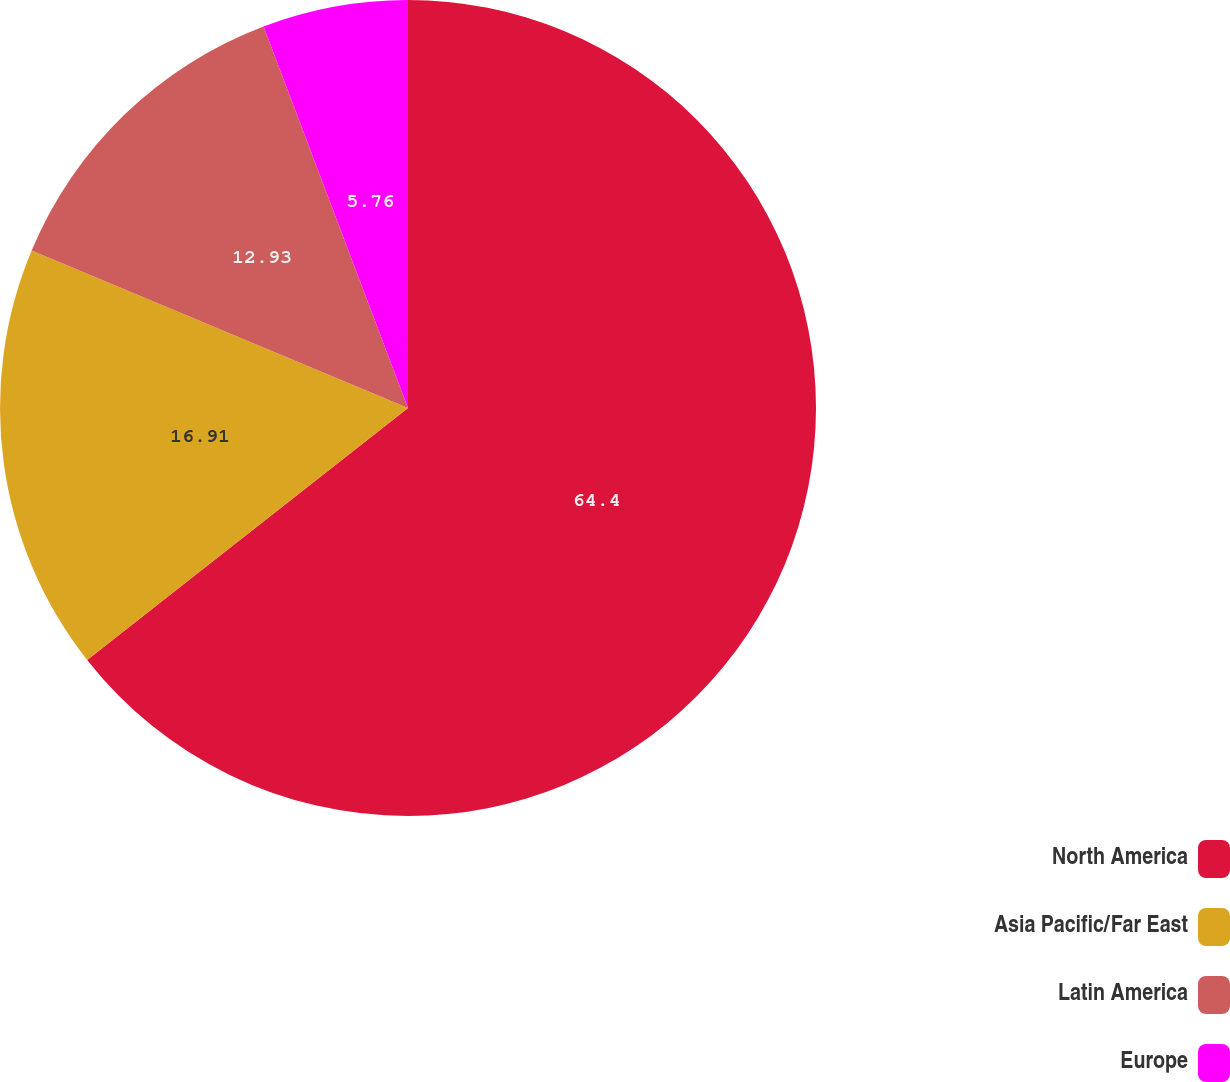Convert chart to OTSL. <chart><loc_0><loc_0><loc_500><loc_500><pie_chart><fcel>North America<fcel>Asia Pacific/Far East<fcel>Latin America<fcel>Europe<nl><fcel>64.41%<fcel>16.91%<fcel>12.93%<fcel>5.76%<nl></chart> 